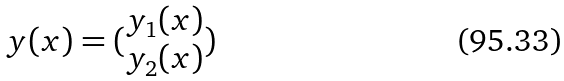<formula> <loc_0><loc_0><loc_500><loc_500>y ( x ) = ( \begin{matrix} y _ { 1 } ( x ) \\ y _ { 2 } ( x ) \end{matrix} )</formula> 